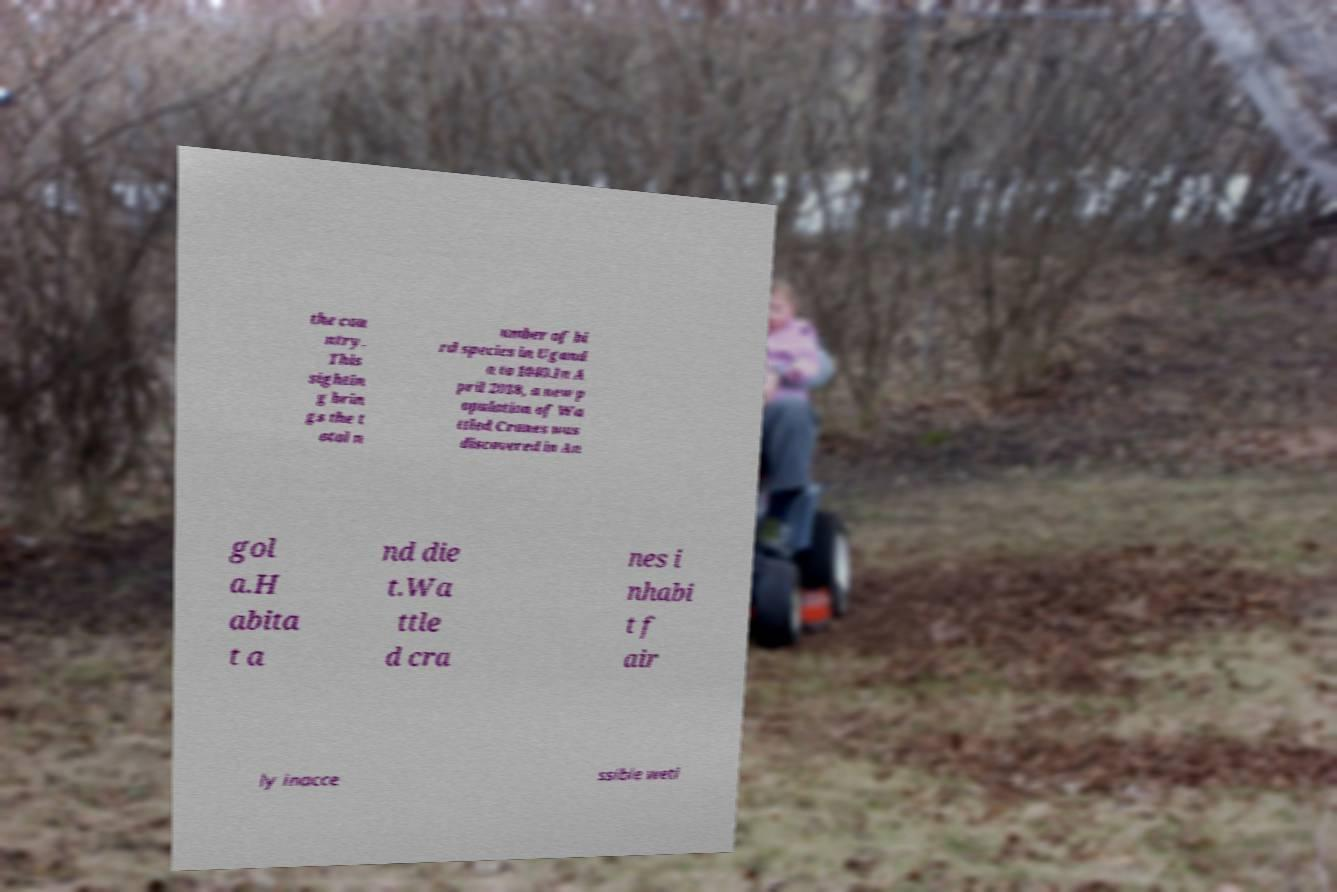Could you extract and type out the text from this image? the cou ntry. This sightin g brin gs the t otal n umber of bi rd species in Ugand a to 1040.In A pril 2018, a new p opulation of Wa ttled Cranes was discovered in An gol a.H abita t a nd die t.Wa ttle d cra nes i nhabi t f air ly inacce ssible wetl 